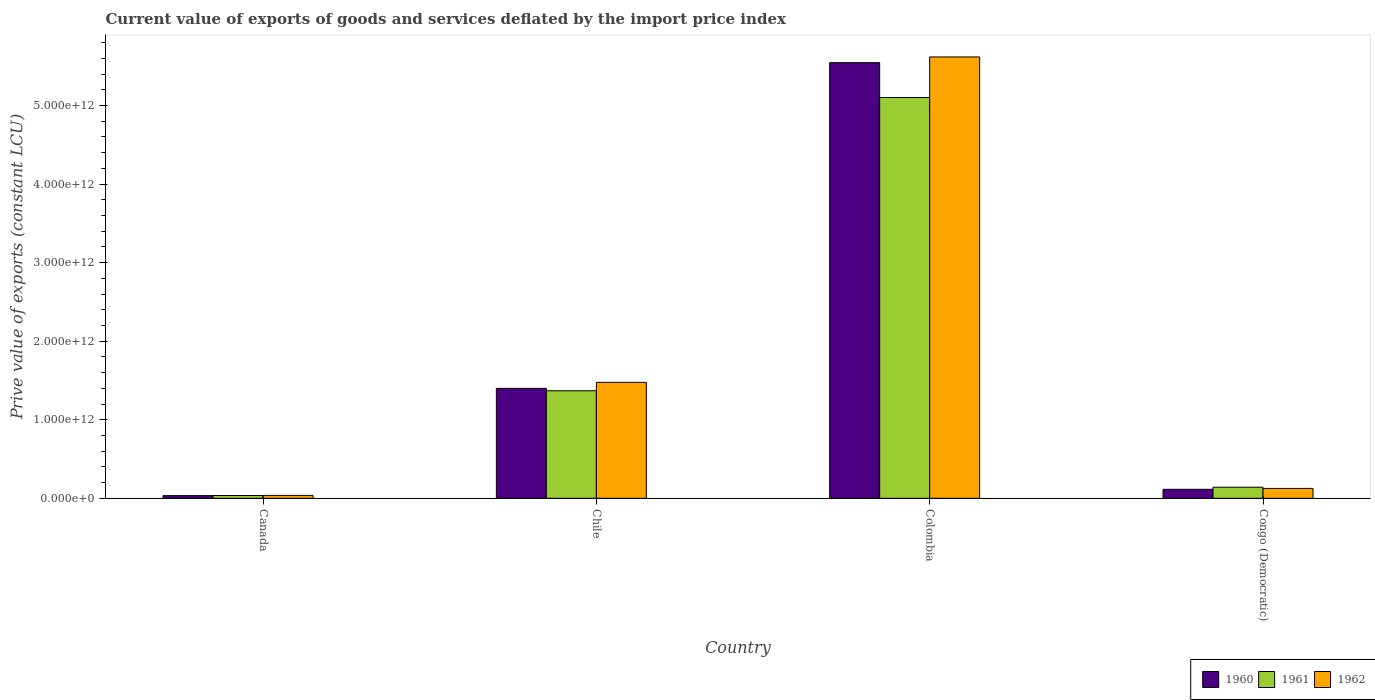How many groups of bars are there?
Offer a terse response. 4. Are the number of bars on each tick of the X-axis equal?
Offer a terse response. Yes. What is the label of the 4th group of bars from the left?
Provide a succinct answer. Congo (Democratic). In how many cases, is the number of bars for a given country not equal to the number of legend labels?
Make the answer very short. 0. What is the prive value of exports in 1960 in Congo (Democratic)?
Offer a very short reply. 1.14e+11. Across all countries, what is the maximum prive value of exports in 1960?
Offer a very short reply. 5.54e+12. Across all countries, what is the minimum prive value of exports in 1961?
Ensure brevity in your answer.  3.55e+1. In which country was the prive value of exports in 1962 maximum?
Keep it short and to the point. Colombia. In which country was the prive value of exports in 1961 minimum?
Offer a very short reply. Canada. What is the total prive value of exports in 1960 in the graph?
Offer a terse response. 7.09e+12. What is the difference between the prive value of exports in 1962 in Canada and that in Congo (Democratic)?
Offer a terse response. -8.86e+1. What is the difference between the prive value of exports in 1962 in Chile and the prive value of exports in 1960 in Congo (Democratic)?
Your answer should be very brief. 1.36e+12. What is the average prive value of exports in 1961 per country?
Your response must be concise. 1.66e+12. What is the difference between the prive value of exports of/in 1960 and prive value of exports of/in 1961 in Congo (Democratic)?
Ensure brevity in your answer.  -2.65e+1. What is the ratio of the prive value of exports in 1962 in Canada to that in Chile?
Provide a short and direct response. 0.02. Is the prive value of exports in 1961 in Chile less than that in Congo (Democratic)?
Offer a terse response. No. What is the difference between the highest and the second highest prive value of exports in 1961?
Your response must be concise. -4.96e+12. What is the difference between the highest and the lowest prive value of exports in 1961?
Make the answer very short. 5.07e+12. Is the sum of the prive value of exports in 1961 in Chile and Congo (Democratic) greater than the maximum prive value of exports in 1960 across all countries?
Provide a short and direct response. No. What does the 3rd bar from the left in Colombia represents?
Your answer should be very brief. 1962. What does the 1st bar from the right in Canada represents?
Keep it short and to the point. 1962. What is the difference between two consecutive major ticks on the Y-axis?
Provide a succinct answer. 1.00e+12. Are the values on the major ticks of Y-axis written in scientific E-notation?
Ensure brevity in your answer.  Yes. Does the graph contain any zero values?
Make the answer very short. No. Does the graph contain grids?
Offer a terse response. No. How many legend labels are there?
Provide a short and direct response. 3. How are the legend labels stacked?
Provide a succinct answer. Horizontal. What is the title of the graph?
Offer a very short reply. Current value of exports of goods and services deflated by the import price index. What is the label or title of the X-axis?
Give a very brief answer. Country. What is the label or title of the Y-axis?
Your answer should be compact. Prive value of exports (constant LCU). What is the Prive value of exports (constant LCU) in 1960 in Canada?
Offer a very short reply. 3.37e+1. What is the Prive value of exports (constant LCU) in 1961 in Canada?
Offer a very short reply. 3.55e+1. What is the Prive value of exports (constant LCU) of 1962 in Canada?
Your answer should be compact. 3.69e+1. What is the Prive value of exports (constant LCU) in 1960 in Chile?
Your response must be concise. 1.40e+12. What is the Prive value of exports (constant LCU) in 1961 in Chile?
Offer a terse response. 1.37e+12. What is the Prive value of exports (constant LCU) in 1962 in Chile?
Your answer should be very brief. 1.48e+12. What is the Prive value of exports (constant LCU) in 1960 in Colombia?
Provide a short and direct response. 5.54e+12. What is the Prive value of exports (constant LCU) in 1961 in Colombia?
Offer a very short reply. 5.10e+12. What is the Prive value of exports (constant LCU) in 1962 in Colombia?
Offer a very short reply. 5.62e+12. What is the Prive value of exports (constant LCU) of 1960 in Congo (Democratic)?
Offer a terse response. 1.14e+11. What is the Prive value of exports (constant LCU) in 1961 in Congo (Democratic)?
Provide a succinct answer. 1.41e+11. What is the Prive value of exports (constant LCU) in 1962 in Congo (Democratic)?
Your answer should be compact. 1.25e+11. Across all countries, what is the maximum Prive value of exports (constant LCU) in 1960?
Make the answer very short. 5.54e+12. Across all countries, what is the maximum Prive value of exports (constant LCU) in 1961?
Your answer should be compact. 5.10e+12. Across all countries, what is the maximum Prive value of exports (constant LCU) of 1962?
Your answer should be compact. 5.62e+12. Across all countries, what is the minimum Prive value of exports (constant LCU) in 1960?
Your answer should be very brief. 3.37e+1. Across all countries, what is the minimum Prive value of exports (constant LCU) of 1961?
Provide a short and direct response. 3.55e+1. Across all countries, what is the minimum Prive value of exports (constant LCU) in 1962?
Your answer should be compact. 3.69e+1. What is the total Prive value of exports (constant LCU) of 1960 in the graph?
Your answer should be very brief. 7.09e+12. What is the total Prive value of exports (constant LCU) in 1961 in the graph?
Your answer should be very brief. 6.65e+12. What is the total Prive value of exports (constant LCU) of 1962 in the graph?
Give a very brief answer. 7.26e+12. What is the difference between the Prive value of exports (constant LCU) in 1960 in Canada and that in Chile?
Provide a short and direct response. -1.37e+12. What is the difference between the Prive value of exports (constant LCU) of 1961 in Canada and that in Chile?
Ensure brevity in your answer.  -1.33e+12. What is the difference between the Prive value of exports (constant LCU) of 1962 in Canada and that in Chile?
Provide a short and direct response. -1.44e+12. What is the difference between the Prive value of exports (constant LCU) of 1960 in Canada and that in Colombia?
Offer a terse response. -5.51e+12. What is the difference between the Prive value of exports (constant LCU) of 1961 in Canada and that in Colombia?
Provide a succinct answer. -5.07e+12. What is the difference between the Prive value of exports (constant LCU) of 1962 in Canada and that in Colombia?
Ensure brevity in your answer.  -5.58e+12. What is the difference between the Prive value of exports (constant LCU) in 1960 in Canada and that in Congo (Democratic)?
Give a very brief answer. -8.07e+1. What is the difference between the Prive value of exports (constant LCU) in 1961 in Canada and that in Congo (Democratic)?
Your answer should be very brief. -1.05e+11. What is the difference between the Prive value of exports (constant LCU) of 1962 in Canada and that in Congo (Democratic)?
Provide a short and direct response. -8.86e+1. What is the difference between the Prive value of exports (constant LCU) of 1960 in Chile and that in Colombia?
Provide a succinct answer. -4.15e+12. What is the difference between the Prive value of exports (constant LCU) of 1961 in Chile and that in Colombia?
Ensure brevity in your answer.  -3.73e+12. What is the difference between the Prive value of exports (constant LCU) in 1962 in Chile and that in Colombia?
Offer a very short reply. -4.14e+12. What is the difference between the Prive value of exports (constant LCU) of 1960 in Chile and that in Congo (Democratic)?
Keep it short and to the point. 1.28e+12. What is the difference between the Prive value of exports (constant LCU) in 1961 in Chile and that in Congo (Democratic)?
Make the answer very short. 1.23e+12. What is the difference between the Prive value of exports (constant LCU) in 1962 in Chile and that in Congo (Democratic)?
Your answer should be compact. 1.35e+12. What is the difference between the Prive value of exports (constant LCU) in 1960 in Colombia and that in Congo (Democratic)?
Offer a terse response. 5.43e+12. What is the difference between the Prive value of exports (constant LCU) of 1961 in Colombia and that in Congo (Democratic)?
Provide a short and direct response. 4.96e+12. What is the difference between the Prive value of exports (constant LCU) of 1962 in Colombia and that in Congo (Democratic)?
Offer a very short reply. 5.49e+12. What is the difference between the Prive value of exports (constant LCU) in 1960 in Canada and the Prive value of exports (constant LCU) in 1961 in Chile?
Make the answer very short. -1.34e+12. What is the difference between the Prive value of exports (constant LCU) of 1960 in Canada and the Prive value of exports (constant LCU) of 1962 in Chile?
Give a very brief answer. -1.44e+12. What is the difference between the Prive value of exports (constant LCU) in 1961 in Canada and the Prive value of exports (constant LCU) in 1962 in Chile?
Offer a very short reply. -1.44e+12. What is the difference between the Prive value of exports (constant LCU) of 1960 in Canada and the Prive value of exports (constant LCU) of 1961 in Colombia?
Offer a very short reply. -5.07e+12. What is the difference between the Prive value of exports (constant LCU) of 1960 in Canada and the Prive value of exports (constant LCU) of 1962 in Colombia?
Offer a terse response. -5.58e+12. What is the difference between the Prive value of exports (constant LCU) in 1961 in Canada and the Prive value of exports (constant LCU) in 1962 in Colombia?
Your response must be concise. -5.58e+12. What is the difference between the Prive value of exports (constant LCU) of 1960 in Canada and the Prive value of exports (constant LCU) of 1961 in Congo (Democratic)?
Offer a terse response. -1.07e+11. What is the difference between the Prive value of exports (constant LCU) of 1960 in Canada and the Prive value of exports (constant LCU) of 1962 in Congo (Democratic)?
Provide a short and direct response. -9.18e+1. What is the difference between the Prive value of exports (constant LCU) of 1961 in Canada and the Prive value of exports (constant LCU) of 1962 in Congo (Democratic)?
Your answer should be compact. -9.00e+1. What is the difference between the Prive value of exports (constant LCU) of 1960 in Chile and the Prive value of exports (constant LCU) of 1961 in Colombia?
Your answer should be compact. -3.70e+12. What is the difference between the Prive value of exports (constant LCU) of 1960 in Chile and the Prive value of exports (constant LCU) of 1962 in Colombia?
Keep it short and to the point. -4.22e+12. What is the difference between the Prive value of exports (constant LCU) in 1961 in Chile and the Prive value of exports (constant LCU) in 1962 in Colombia?
Your answer should be compact. -4.25e+12. What is the difference between the Prive value of exports (constant LCU) in 1960 in Chile and the Prive value of exports (constant LCU) in 1961 in Congo (Democratic)?
Provide a short and direct response. 1.26e+12. What is the difference between the Prive value of exports (constant LCU) in 1960 in Chile and the Prive value of exports (constant LCU) in 1962 in Congo (Democratic)?
Your answer should be compact. 1.27e+12. What is the difference between the Prive value of exports (constant LCU) of 1961 in Chile and the Prive value of exports (constant LCU) of 1962 in Congo (Democratic)?
Provide a succinct answer. 1.24e+12. What is the difference between the Prive value of exports (constant LCU) in 1960 in Colombia and the Prive value of exports (constant LCU) in 1961 in Congo (Democratic)?
Provide a short and direct response. 5.40e+12. What is the difference between the Prive value of exports (constant LCU) of 1960 in Colombia and the Prive value of exports (constant LCU) of 1962 in Congo (Democratic)?
Offer a terse response. 5.42e+12. What is the difference between the Prive value of exports (constant LCU) of 1961 in Colombia and the Prive value of exports (constant LCU) of 1962 in Congo (Democratic)?
Give a very brief answer. 4.98e+12. What is the average Prive value of exports (constant LCU) of 1960 per country?
Provide a short and direct response. 1.77e+12. What is the average Prive value of exports (constant LCU) of 1961 per country?
Keep it short and to the point. 1.66e+12. What is the average Prive value of exports (constant LCU) in 1962 per country?
Offer a very short reply. 1.81e+12. What is the difference between the Prive value of exports (constant LCU) in 1960 and Prive value of exports (constant LCU) in 1961 in Canada?
Give a very brief answer. -1.81e+09. What is the difference between the Prive value of exports (constant LCU) of 1960 and Prive value of exports (constant LCU) of 1962 in Canada?
Provide a succinct answer. -3.23e+09. What is the difference between the Prive value of exports (constant LCU) in 1961 and Prive value of exports (constant LCU) in 1962 in Canada?
Your answer should be very brief. -1.41e+09. What is the difference between the Prive value of exports (constant LCU) of 1960 and Prive value of exports (constant LCU) of 1961 in Chile?
Keep it short and to the point. 3.03e+1. What is the difference between the Prive value of exports (constant LCU) in 1960 and Prive value of exports (constant LCU) in 1962 in Chile?
Ensure brevity in your answer.  -7.65e+1. What is the difference between the Prive value of exports (constant LCU) of 1961 and Prive value of exports (constant LCU) of 1962 in Chile?
Give a very brief answer. -1.07e+11. What is the difference between the Prive value of exports (constant LCU) in 1960 and Prive value of exports (constant LCU) in 1961 in Colombia?
Offer a very short reply. 4.44e+11. What is the difference between the Prive value of exports (constant LCU) of 1960 and Prive value of exports (constant LCU) of 1962 in Colombia?
Give a very brief answer. -7.31e+1. What is the difference between the Prive value of exports (constant LCU) in 1961 and Prive value of exports (constant LCU) in 1962 in Colombia?
Your response must be concise. -5.17e+11. What is the difference between the Prive value of exports (constant LCU) in 1960 and Prive value of exports (constant LCU) in 1961 in Congo (Democratic)?
Your answer should be compact. -2.65e+1. What is the difference between the Prive value of exports (constant LCU) in 1960 and Prive value of exports (constant LCU) in 1962 in Congo (Democratic)?
Provide a succinct answer. -1.11e+1. What is the difference between the Prive value of exports (constant LCU) in 1961 and Prive value of exports (constant LCU) in 1962 in Congo (Democratic)?
Provide a succinct answer. 1.54e+1. What is the ratio of the Prive value of exports (constant LCU) of 1960 in Canada to that in Chile?
Provide a succinct answer. 0.02. What is the ratio of the Prive value of exports (constant LCU) in 1961 in Canada to that in Chile?
Offer a very short reply. 0.03. What is the ratio of the Prive value of exports (constant LCU) of 1962 in Canada to that in Chile?
Offer a very short reply. 0.03. What is the ratio of the Prive value of exports (constant LCU) in 1960 in Canada to that in Colombia?
Your answer should be compact. 0.01. What is the ratio of the Prive value of exports (constant LCU) in 1961 in Canada to that in Colombia?
Keep it short and to the point. 0.01. What is the ratio of the Prive value of exports (constant LCU) of 1962 in Canada to that in Colombia?
Your response must be concise. 0.01. What is the ratio of the Prive value of exports (constant LCU) in 1960 in Canada to that in Congo (Democratic)?
Provide a short and direct response. 0.29. What is the ratio of the Prive value of exports (constant LCU) of 1961 in Canada to that in Congo (Democratic)?
Your response must be concise. 0.25. What is the ratio of the Prive value of exports (constant LCU) in 1962 in Canada to that in Congo (Democratic)?
Ensure brevity in your answer.  0.29. What is the ratio of the Prive value of exports (constant LCU) in 1960 in Chile to that in Colombia?
Make the answer very short. 0.25. What is the ratio of the Prive value of exports (constant LCU) in 1961 in Chile to that in Colombia?
Your response must be concise. 0.27. What is the ratio of the Prive value of exports (constant LCU) of 1962 in Chile to that in Colombia?
Provide a short and direct response. 0.26. What is the ratio of the Prive value of exports (constant LCU) of 1960 in Chile to that in Congo (Democratic)?
Provide a short and direct response. 12.24. What is the ratio of the Prive value of exports (constant LCU) of 1961 in Chile to that in Congo (Democratic)?
Give a very brief answer. 9.71. What is the ratio of the Prive value of exports (constant LCU) of 1962 in Chile to that in Congo (Democratic)?
Ensure brevity in your answer.  11.76. What is the ratio of the Prive value of exports (constant LCU) of 1960 in Colombia to that in Congo (Democratic)?
Your answer should be very brief. 48.49. What is the ratio of the Prive value of exports (constant LCU) in 1961 in Colombia to that in Congo (Democratic)?
Provide a short and direct response. 36.21. What is the ratio of the Prive value of exports (constant LCU) in 1962 in Colombia to that in Congo (Democratic)?
Provide a succinct answer. 44.77. What is the difference between the highest and the second highest Prive value of exports (constant LCU) of 1960?
Keep it short and to the point. 4.15e+12. What is the difference between the highest and the second highest Prive value of exports (constant LCU) of 1961?
Your answer should be very brief. 3.73e+12. What is the difference between the highest and the second highest Prive value of exports (constant LCU) of 1962?
Provide a succinct answer. 4.14e+12. What is the difference between the highest and the lowest Prive value of exports (constant LCU) of 1960?
Your response must be concise. 5.51e+12. What is the difference between the highest and the lowest Prive value of exports (constant LCU) in 1961?
Offer a very short reply. 5.07e+12. What is the difference between the highest and the lowest Prive value of exports (constant LCU) in 1962?
Provide a short and direct response. 5.58e+12. 